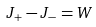Convert formula to latex. <formula><loc_0><loc_0><loc_500><loc_500>J _ { + } - J _ { - } = W</formula> 